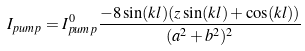Convert formula to latex. <formula><loc_0><loc_0><loc_500><loc_500>I _ { p u m p } = I ^ { 0 } _ { p u m p } \frac { - 8 \sin ( k l ) ( z \sin ( k l ) + \cos ( k l ) ) } { ( a ^ { 2 } + b ^ { 2 } ) ^ { 2 } }</formula> 